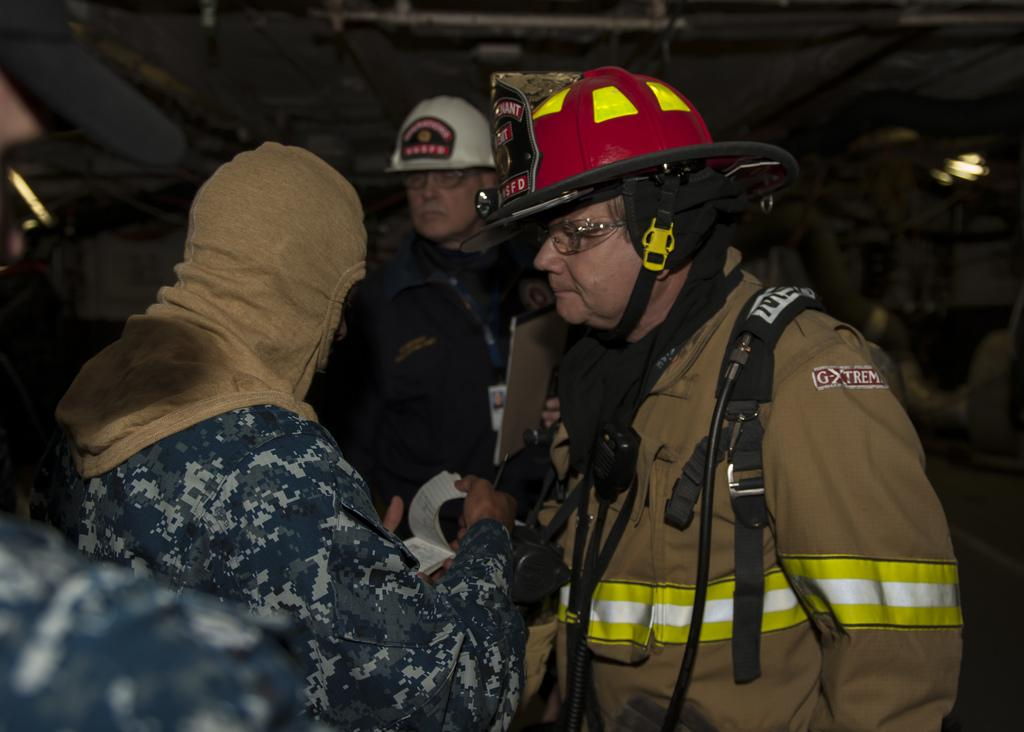What types of professionals are present in the image? There are firefighters and soldiers in the image. What might be the reason for their presence in the image? It is possible that they are responding to an emergency or disaster, given the presence of a demolished building in the background. What type of board game is being played by the firefighters and soldiers in the image? There is no board game present in the image; the firefighters and soldiers are likely attending to a situation involving the demolished building. 